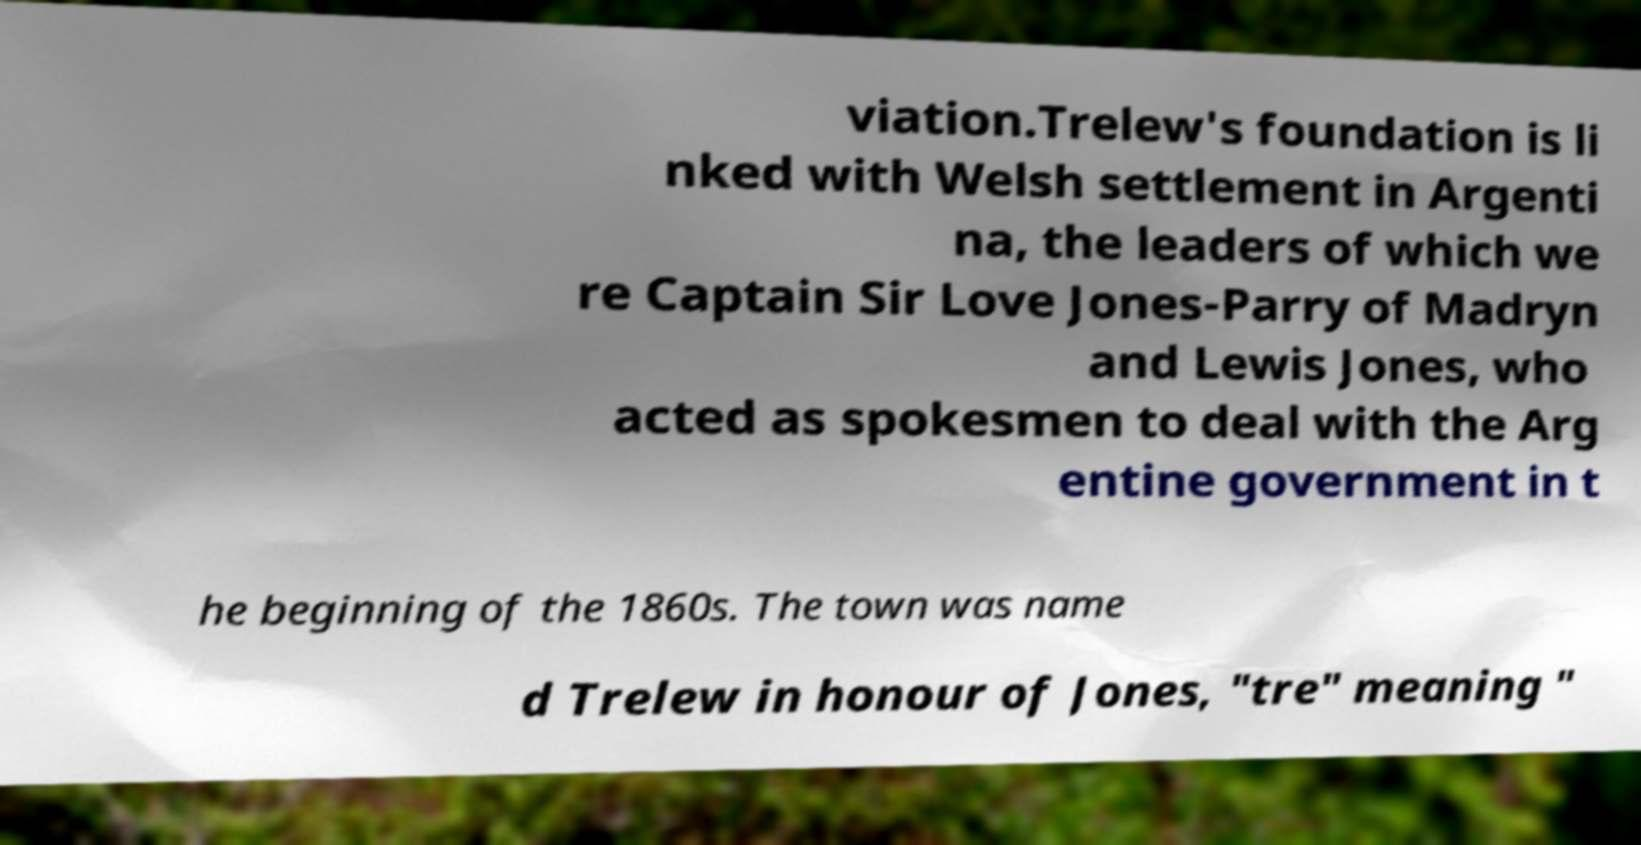Could you assist in decoding the text presented in this image and type it out clearly? viation.Trelew's foundation is li nked with Welsh settlement in Argenti na, the leaders of which we re Captain Sir Love Jones-Parry of Madryn and Lewis Jones, who acted as spokesmen to deal with the Arg entine government in t he beginning of the 1860s. The town was name d Trelew in honour of Jones, "tre" meaning " 